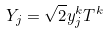<formula> <loc_0><loc_0><loc_500><loc_500>Y _ { j } = \sqrt { 2 } y _ { j } ^ { k } T ^ { k }</formula> 